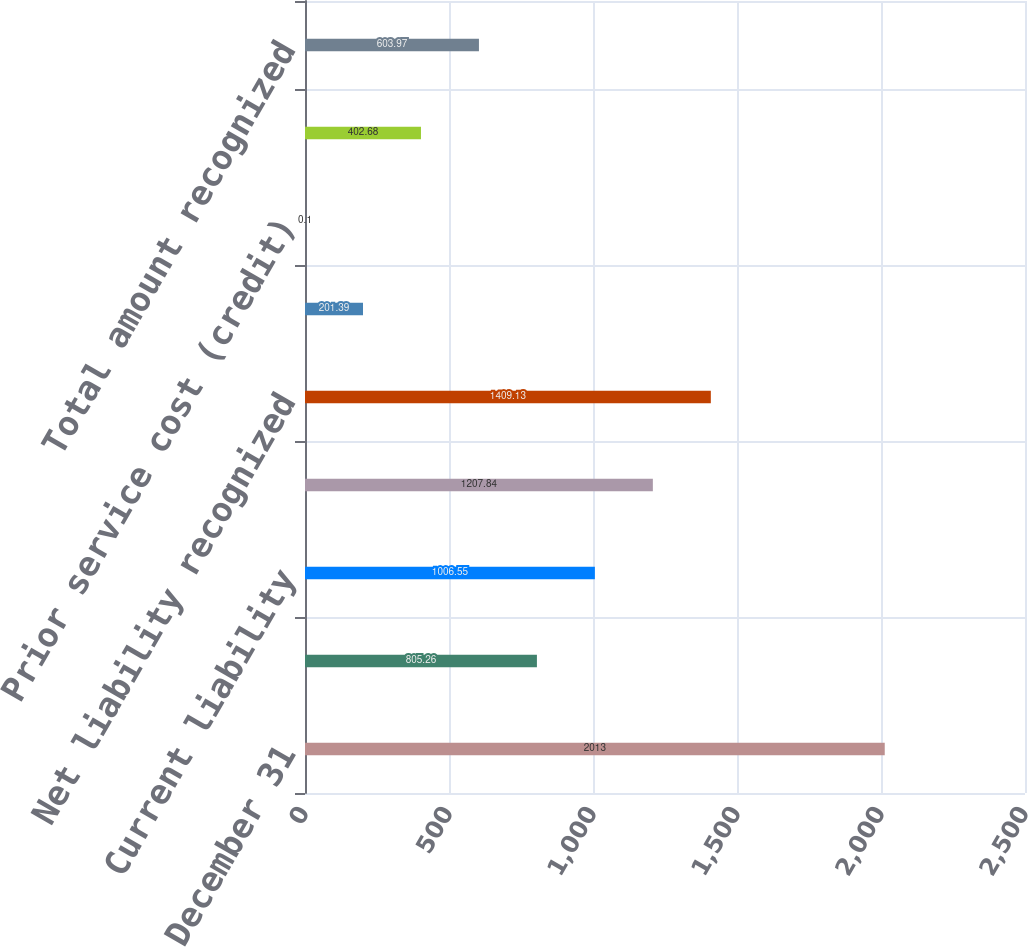<chart> <loc_0><loc_0><loc_500><loc_500><bar_chart><fcel>December 31<fcel>Non-current asset<fcel>Current liability<fcel>Non-current liability<fcel>Net liability recognized<fcel>Net actuarial loss (gain)<fcel>Prior service cost (credit)<fcel>Transition obligation<fcel>Total amount recognized<nl><fcel>2013<fcel>805.26<fcel>1006.55<fcel>1207.84<fcel>1409.13<fcel>201.39<fcel>0.1<fcel>402.68<fcel>603.97<nl></chart> 